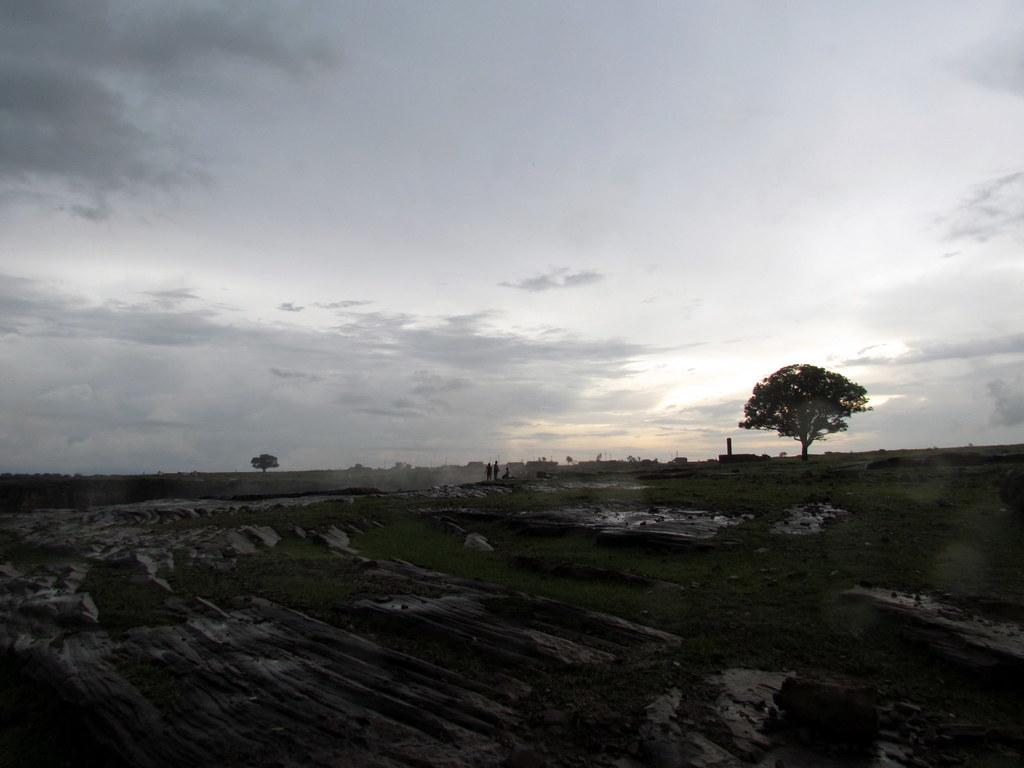What is the main feature of the image? The center of the image contains the sky. What can be seen in the sky? Clouds are visible in the sky. What type of vegetation is present in the image? Trees are present in the image. What structures can be seen in the image? Poles are in the image. What is the ground surface like in the image? Grass is visible in the image. Are there any living beings in the image? Yes, there are people in the image. How much money is being exchanged between the people in the image? There is no indication of money exchange in the image; it only shows people, trees, poles, grass, and the sky with clouds. 